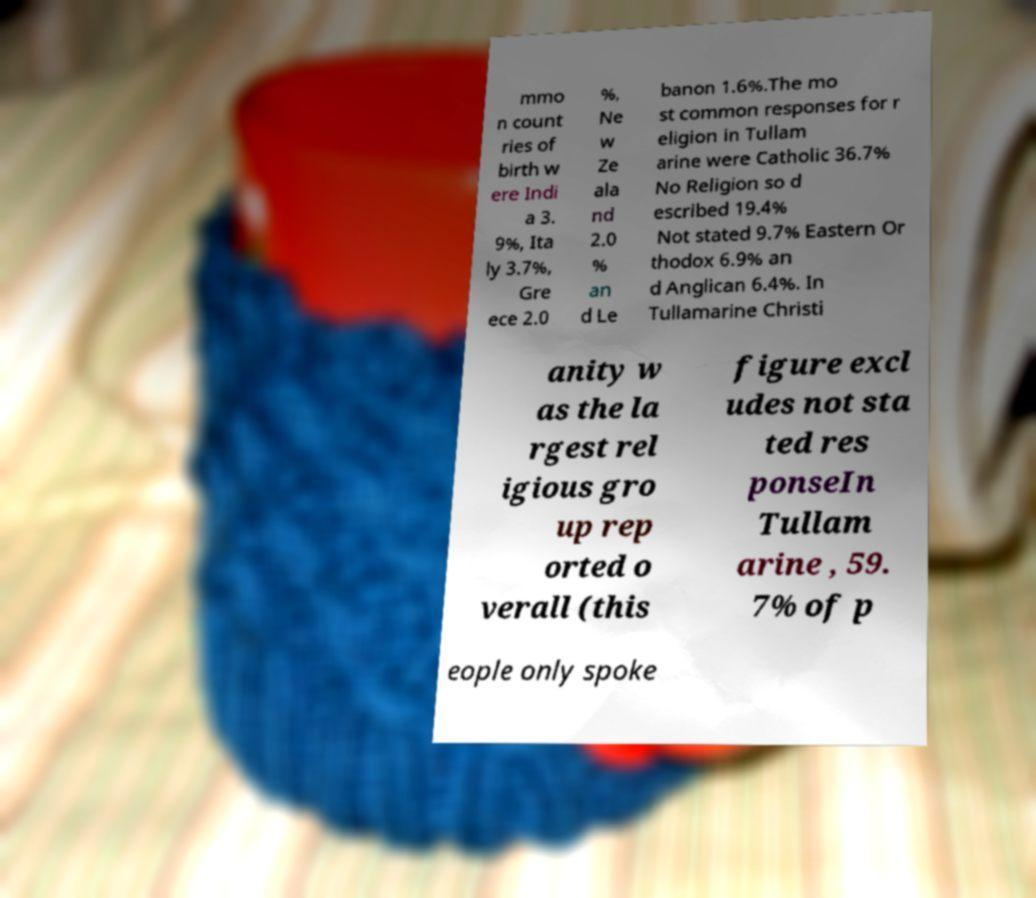There's text embedded in this image that I need extracted. Can you transcribe it verbatim? mmo n count ries of birth w ere Indi a 3. 9%, Ita ly 3.7%, Gre ece 2.0 %, Ne w Ze ala nd 2.0 % an d Le banon 1.6%.The mo st common responses for r eligion in Tullam arine were Catholic 36.7% No Religion so d escribed 19.4% Not stated 9.7% Eastern Or thodox 6.9% an d Anglican 6.4%. In Tullamarine Christi anity w as the la rgest rel igious gro up rep orted o verall (this figure excl udes not sta ted res ponseIn Tullam arine , 59. 7% of p eople only spoke 